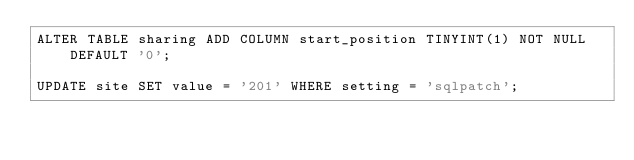<code> <loc_0><loc_0><loc_500><loc_500><_SQL_>ALTER TABLE sharing ADD COLUMN start_position TINYINT(1) NOT NULL DEFAULT '0';

UPDATE site SET value = '201' WHERE setting = 'sqlpatch';
</code> 